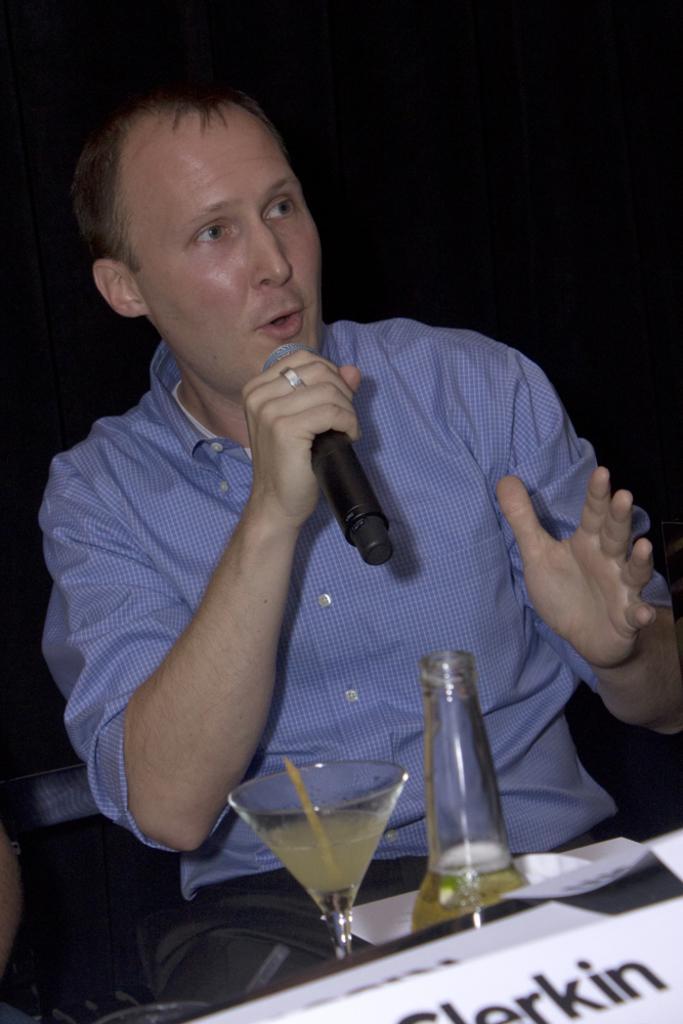How would you summarize this image in a sentence or two? There is a man who is talking on the mike. This is chair. And there is a glass and bottle. 